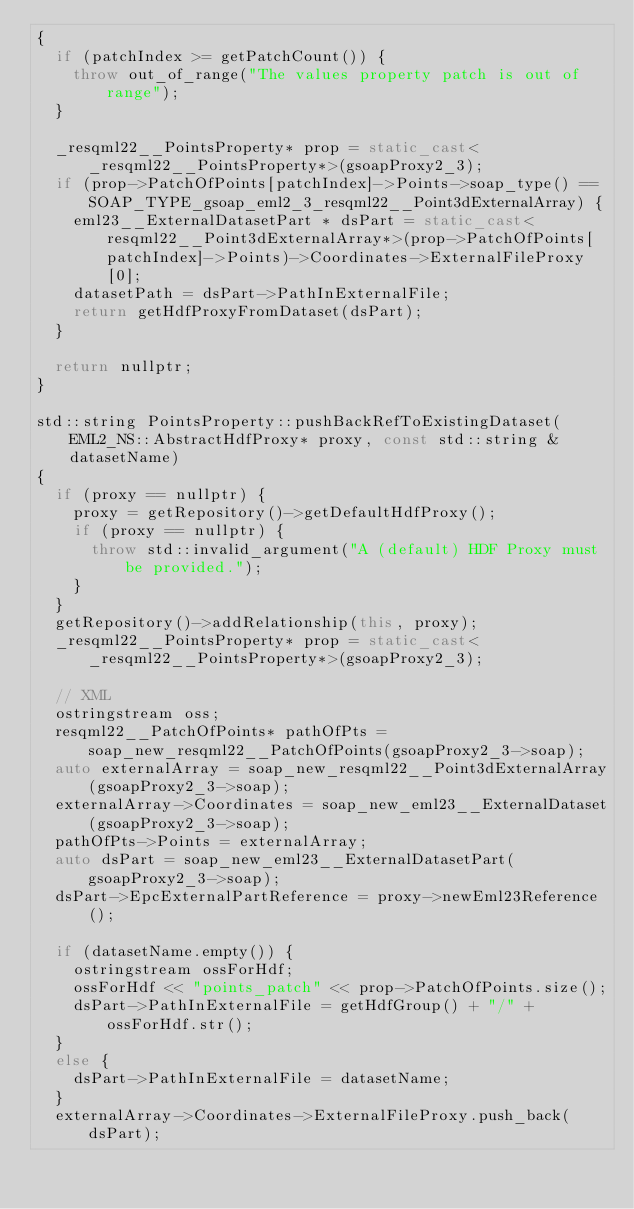<code> <loc_0><loc_0><loc_500><loc_500><_C++_>{
	if (patchIndex >= getPatchCount()) {
		throw out_of_range("The values property patch is out of range");
	}

	_resqml22__PointsProperty* prop = static_cast<_resqml22__PointsProperty*>(gsoapProxy2_3);
	if (prop->PatchOfPoints[patchIndex]->Points->soap_type() == SOAP_TYPE_gsoap_eml2_3_resqml22__Point3dExternalArray) {
		eml23__ExternalDatasetPart * dsPart = static_cast<resqml22__Point3dExternalArray*>(prop->PatchOfPoints[patchIndex]->Points)->Coordinates->ExternalFileProxy[0];
		datasetPath = dsPart->PathInExternalFile;
		return getHdfProxyFromDataset(dsPart);
	}

	return nullptr;
}

std::string PointsProperty::pushBackRefToExistingDataset(EML2_NS::AbstractHdfProxy* proxy, const std::string & datasetName)
{
	if (proxy == nullptr) {
		proxy = getRepository()->getDefaultHdfProxy();
		if (proxy == nullptr) {
			throw std::invalid_argument("A (default) HDF Proxy must be provided.");
		}
	}
	getRepository()->addRelationship(this, proxy);
	_resqml22__PointsProperty* prop = static_cast<_resqml22__PointsProperty*>(gsoapProxy2_3);

	// XML
	ostringstream oss;
	resqml22__PatchOfPoints* pathOfPts = soap_new_resqml22__PatchOfPoints(gsoapProxy2_3->soap);
	auto externalArray = soap_new_resqml22__Point3dExternalArray(gsoapProxy2_3->soap);
	externalArray->Coordinates = soap_new_eml23__ExternalDataset(gsoapProxy2_3->soap);
	pathOfPts->Points = externalArray;
	auto dsPart = soap_new_eml23__ExternalDatasetPart(gsoapProxy2_3->soap);
	dsPart->EpcExternalPartReference = proxy->newEml23Reference();

	if (datasetName.empty()) {
		ostringstream ossForHdf;
		ossForHdf << "points_patch" << prop->PatchOfPoints.size();
		dsPart->PathInExternalFile = getHdfGroup() + "/" + ossForHdf.str();
	}
	else {
		dsPart->PathInExternalFile = datasetName;
	}
	externalArray->Coordinates->ExternalFileProxy.push_back(dsPart);
</code> 